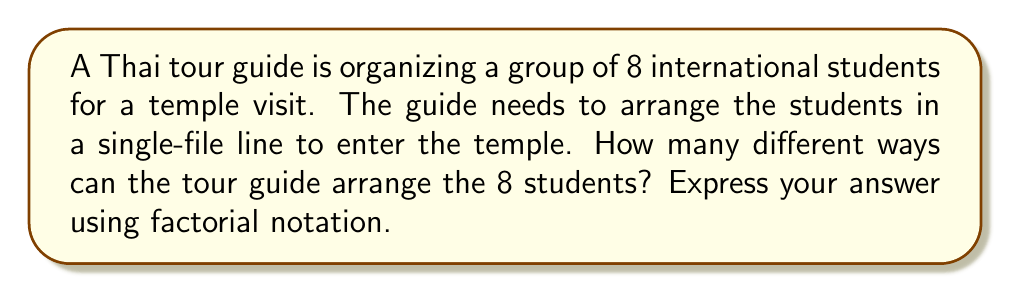What is the answer to this math problem? To solve this problem, we need to understand the concept of permutations in group theory.

1) In this case, we are arranging 8 distinct students in a line. This is a perfect example of a permutation without repetition.

2) The number of ways to arrange n distinct objects is given by n!

3) Here, n = 8 (the number of students)

4) Therefore, the number of possible arrangements is 8!

5) To understand why this is true, let's break it down:
   - For the first position, we have 8 choices
   - For the second position, we have 7 remaining choices
   - For the third position, we have 6 remaining choices
   - And so on...

6) Mathematically, this can be expressed as:

   $$ 8 \times 7 \times 6 \times 5 \times 4 \times 3 \times 2 \times 1 = 8! $$

7) The order of the permutation group for arranging 8 students is thus 8!

Note: In group theory, this is equivalent to finding the order of the symmetric group $S_8$.
Answer: $8!$ 